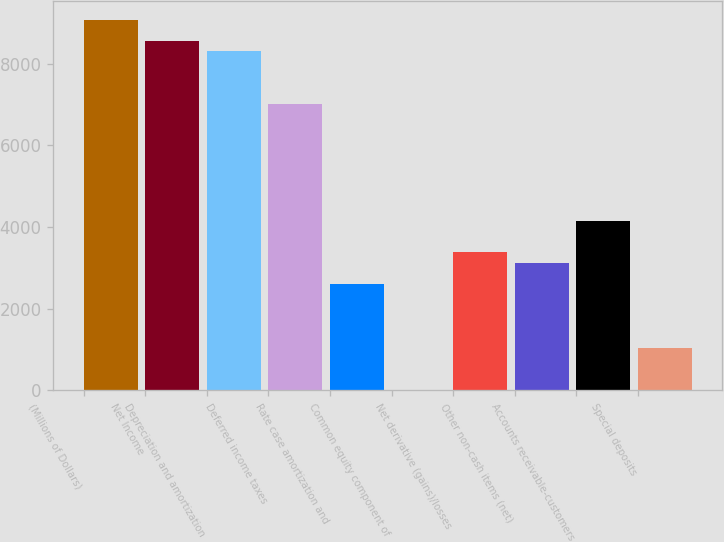Convert chart. <chart><loc_0><loc_0><loc_500><loc_500><bar_chart><fcel>(Millions of Dollars)<fcel>Net Income<fcel>Depreciation and amortization<fcel>Deferred income taxes<fcel>Rate case amortization and<fcel>Common equity component of<fcel>Net derivative (gains)/losses<fcel>Other non-cash items (net)<fcel>Accounts receivable-customers<fcel>Special deposits<nl><fcel>9086.5<fcel>8567.5<fcel>8308<fcel>7010.5<fcel>2599<fcel>4<fcel>3377.5<fcel>3118<fcel>4156<fcel>1042<nl></chart> 